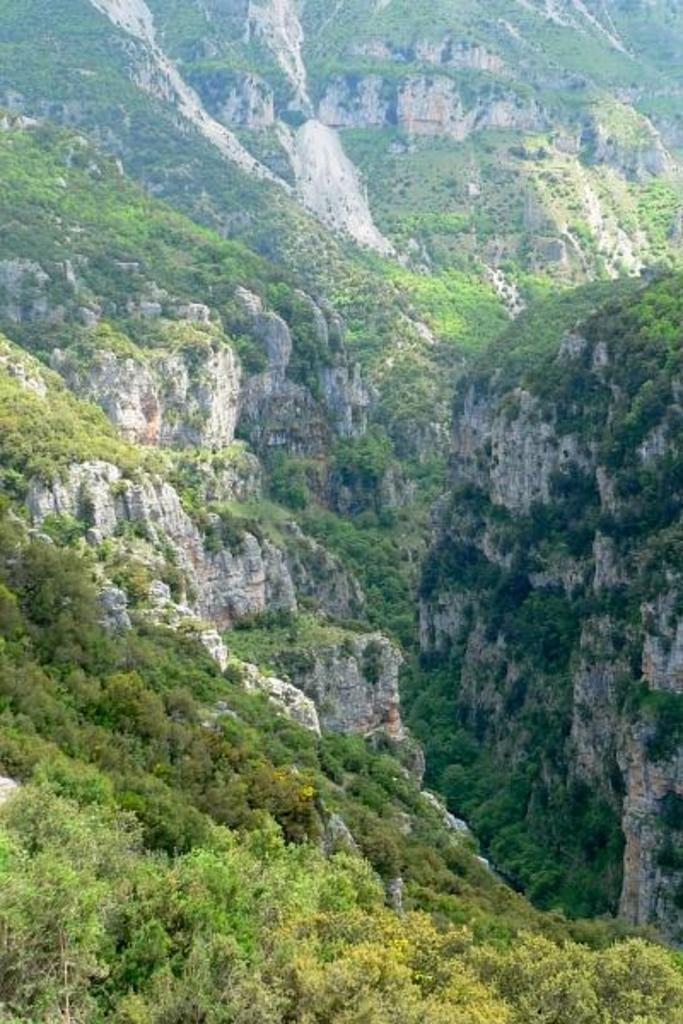What type of natural landscape can be seen in the image? There are hills and trees in the image. Can you describe the vegetation present in the image? The image features trees. How many cushions can be seen on the hills in the image? There are no cushions present in the image; it features hills and trees. How many girls are visible in the image? There is no mention of girls in the provided facts, so we cannot determine their presence in the image. 